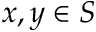Convert formula to latex. <formula><loc_0><loc_0><loc_500><loc_500>x , y \in S</formula> 